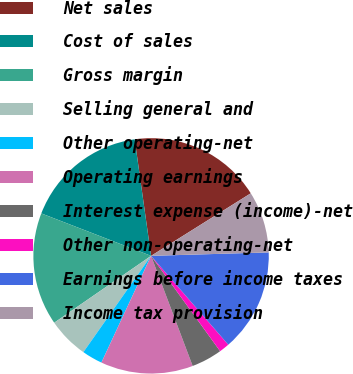Convert chart. <chart><loc_0><loc_0><loc_500><loc_500><pie_chart><fcel>Net sales<fcel>Cost of sales<fcel>Gross margin<fcel>Selling general and<fcel>Other operating-net<fcel>Operating earnings<fcel>Interest expense (income)-net<fcel>Other non-operating-net<fcel>Earnings before income taxes<fcel>Income tax provision<nl><fcel>18.31%<fcel>16.9%<fcel>15.49%<fcel>5.63%<fcel>2.82%<fcel>12.68%<fcel>4.23%<fcel>1.41%<fcel>14.08%<fcel>8.45%<nl></chart> 